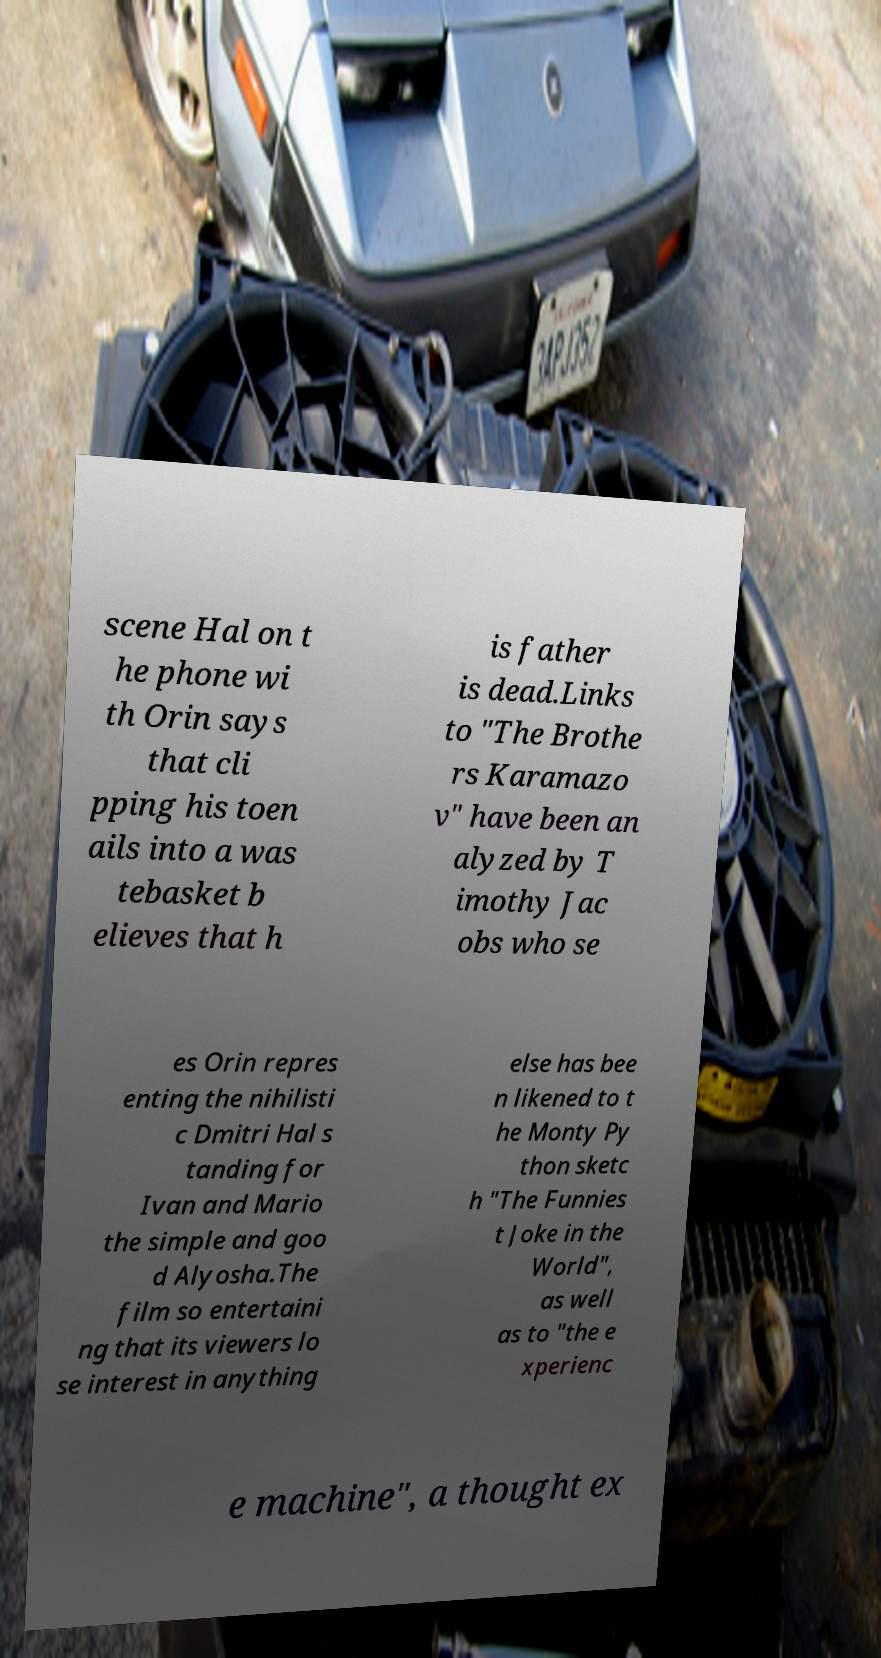Please read and relay the text visible in this image. What does it say? scene Hal on t he phone wi th Orin says that cli pping his toen ails into a was tebasket b elieves that h is father is dead.Links to "The Brothe rs Karamazo v" have been an alyzed by T imothy Jac obs who se es Orin repres enting the nihilisti c Dmitri Hal s tanding for Ivan and Mario the simple and goo d Alyosha.The film so entertaini ng that its viewers lo se interest in anything else has bee n likened to t he Monty Py thon sketc h "The Funnies t Joke in the World", as well as to "the e xperienc e machine", a thought ex 